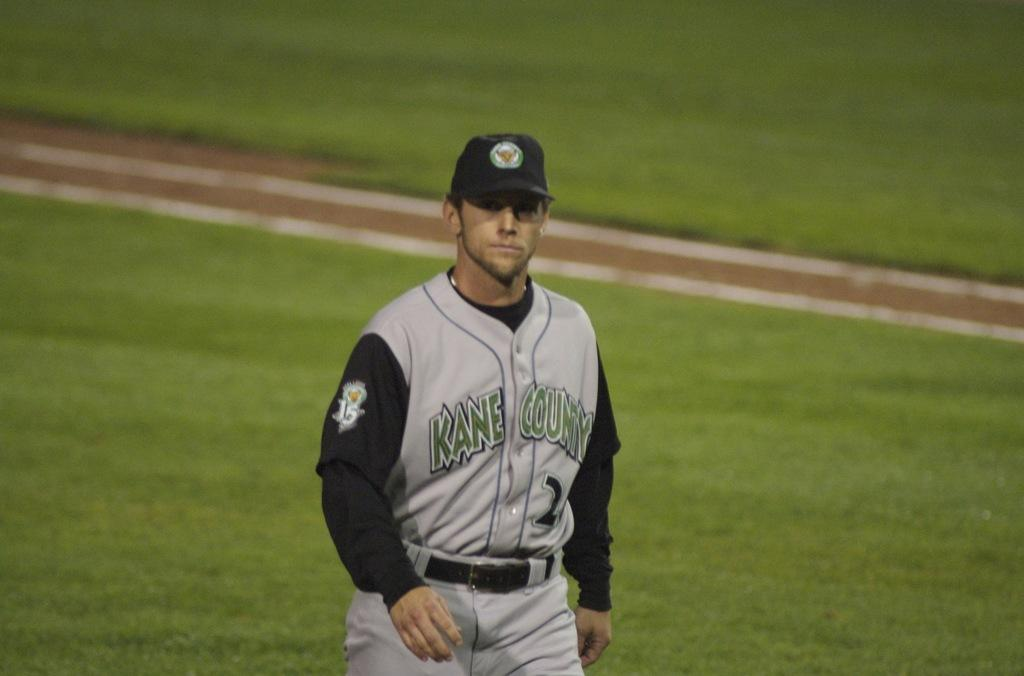Provide a one-sentence caption for the provided image. A Kane County baseball player wearing black and grey looks at the camera as he walks on the playing field. 